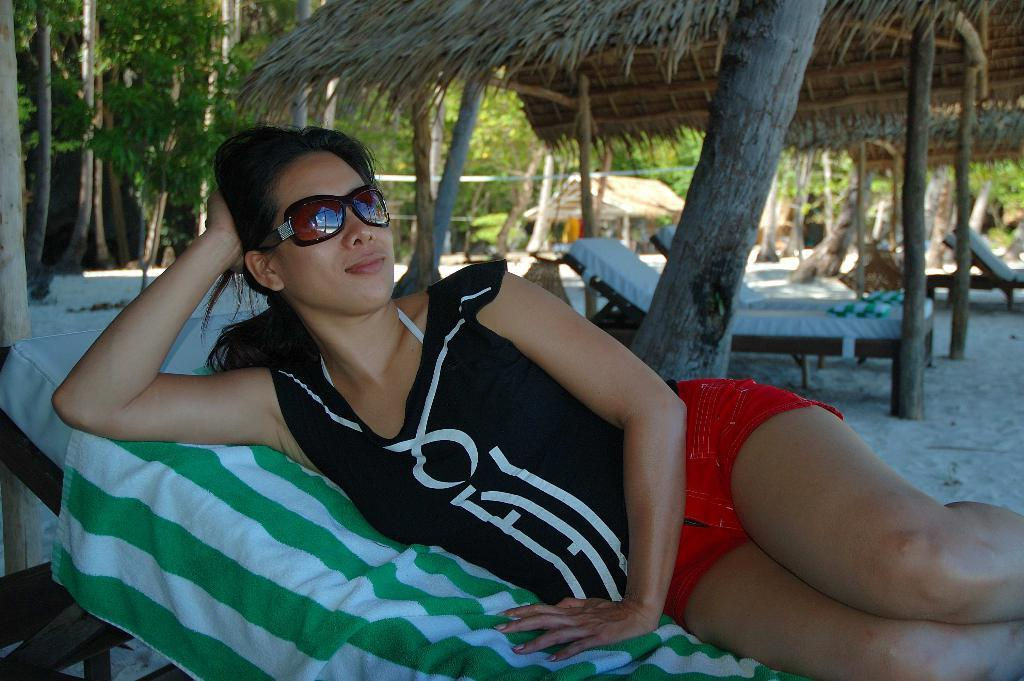What type of furniture is in the center of the image? There are chair lounges in the center of the image. What is the lady in the image doing? A lady is lying on a chair lounge. What item is present that might be used for drying or covering? There is a towel present. What can be seen in the background of the image? There is a shed, trees, and a fence visible in the background. What type of art is displayed on the shed in the image? There is no art displayed on the shed in the image; it is a simple structure in the background. 